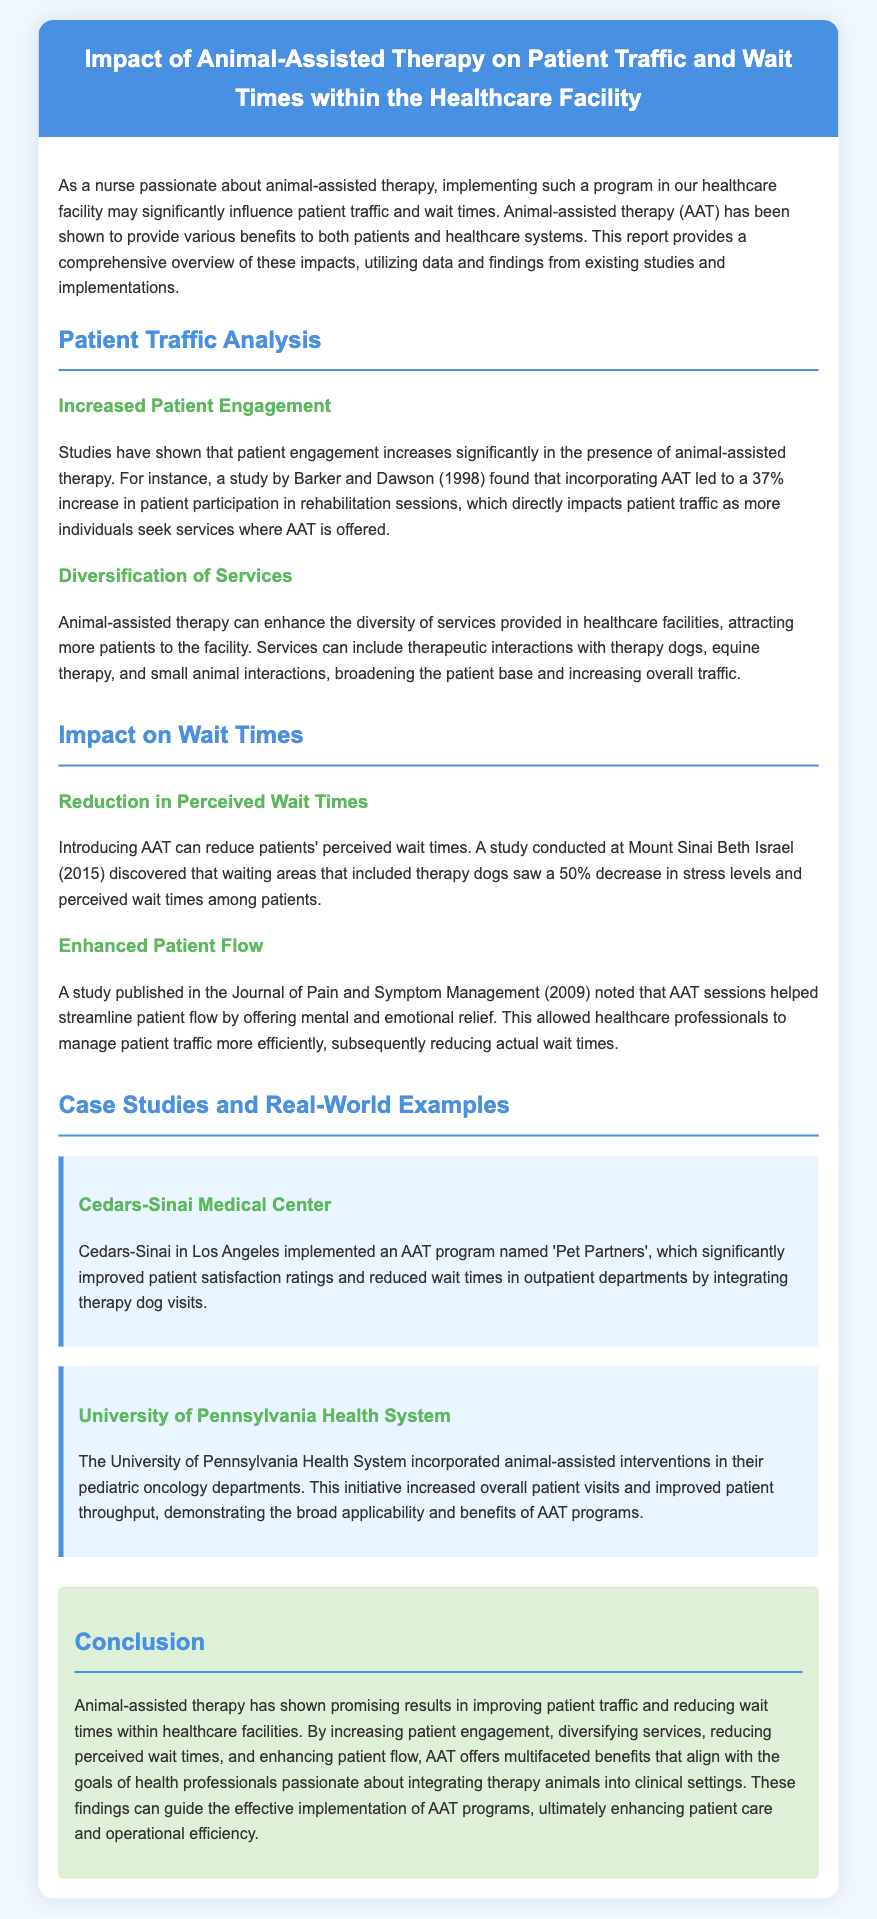what is the percentage increase in patient participation due to AAT? A study by Barker and Dawson (1998) found a 37% increase in patient participation in rehabilitation sessions with AAT.
Answer: 37% which medical center implemented the 'Pet Partners' AAT program? Cedars-Sinai Medical Center in Los Angeles implemented the 'Pet Partners' AAT program.
Answer: Cedars-Sinai Medical Center what reduction in stress levels was reported in waiting areas with therapy dogs? A study conducted at Mount Sinai Beth Israel (2015) discovered a 50% decrease in stress levels among patients.
Answer: 50% what is one benefit of AAT mentioned regarding patient flow? A study published in the Journal of Pain and Symptom Management (2009) noted that AAT sessions helped streamline patient flow.
Answer: Streamline patient flow which healthcare facility incorporated AAT in their pediatric oncology department? The University of Pennsylvania Health System included animal-assisted interventions in their pediatric oncology departments.
Answer: University of Pennsylvania Health System what is one way AAT enhances the diversity of services provided? AAT can enhance services by including therapeutic interactions with therapy dogs, equine therapy, and small animal interactions.
Answer: Therapeutic interactions what year did the study at Mount Sinai Beth Israel take place? The study regarding therapy dogs was conducted in 2015.
Answer: 2015 what primary goal does AAT help achieve in healthcare facilities? AAT offers multifaceted benefits that align with enhancing patient care and operational efficiency.
Answer: Enhancing patient care 